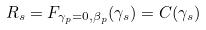Convert formula to latex. <formula><loc_0><loc_0><loc_500><loc_500>R _ { s } = F _ { \gamma _ { p } = 0 , \beta _ { p } } ( \gamma _ { s } ) = C ( \gamma _ { s } )</formula> 